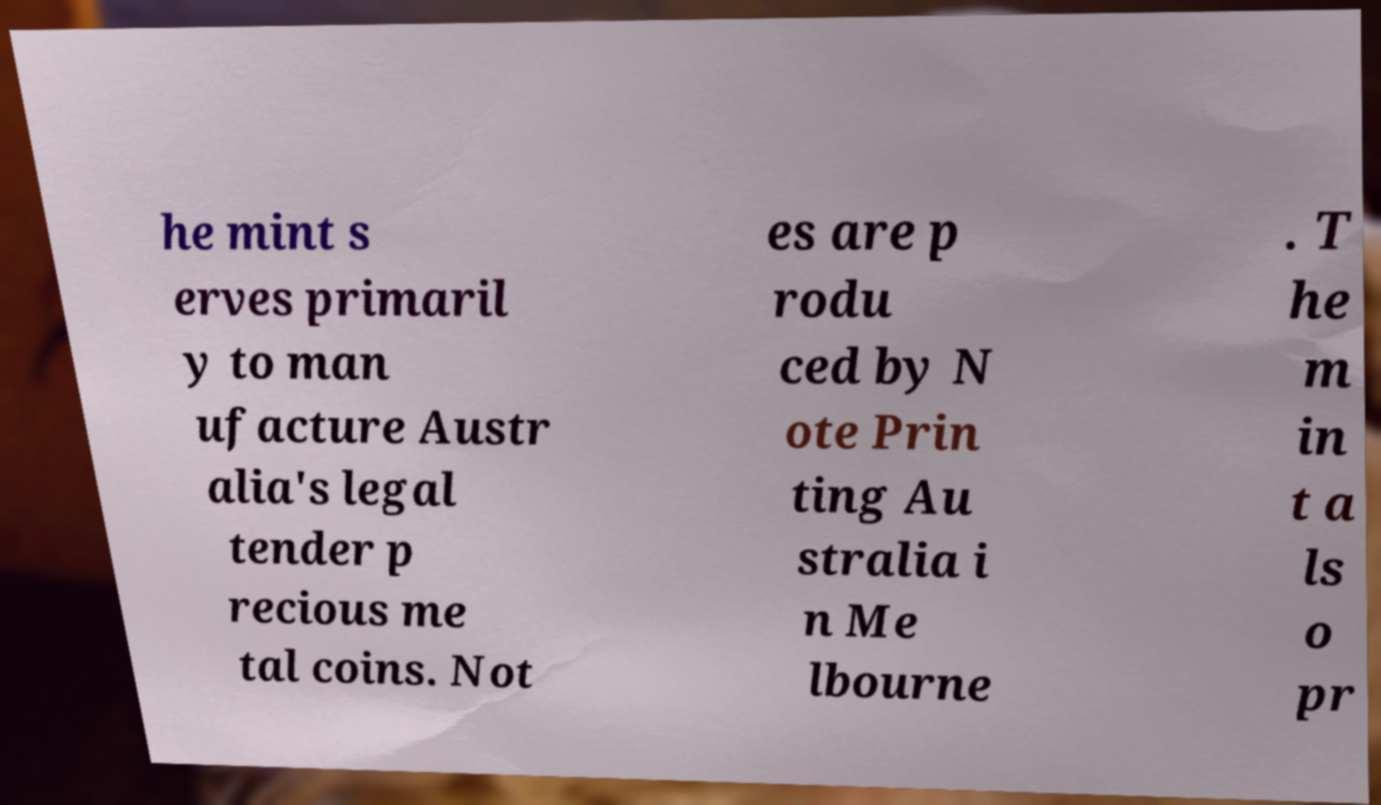For documentation purposes, I need the text within this image transcribed. Could you provide that? he mint s erves primaril y to man ufacture Austr alia's legal tender p recious me tal coins. Not es are p rodu ced by N ote Prin ting Au stralia i n Me lbourne . T he m in t a ls o pr 